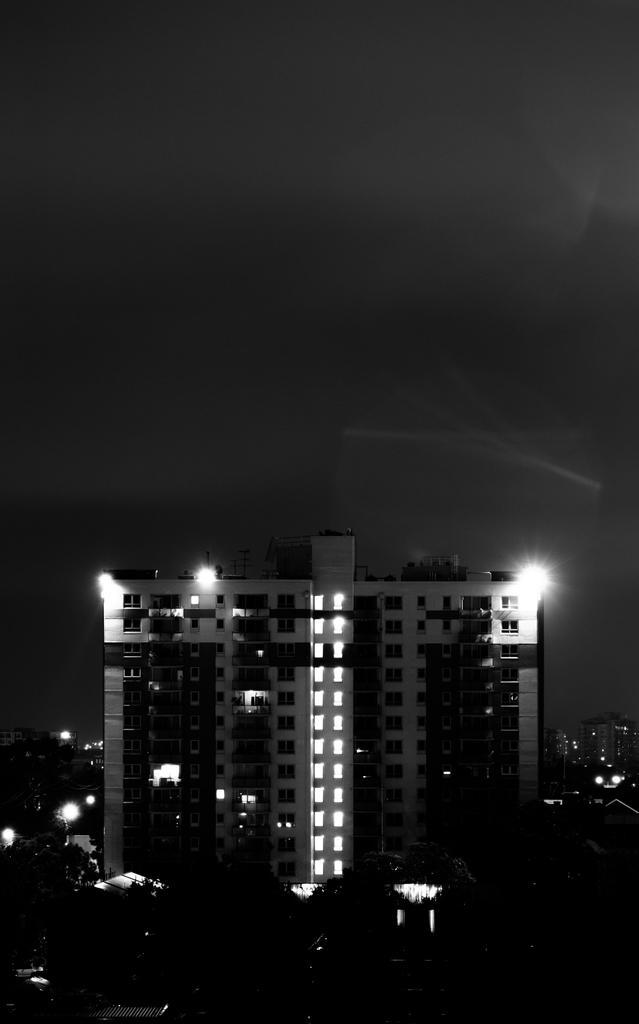Could you give a brief overview of what you see in this image? I can see this is a black and white picture. There are trees, buildings, lights and in the background there is sky. 